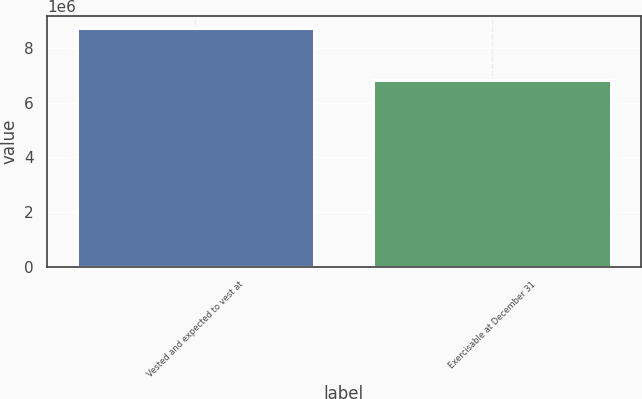Convert chart. <chart><loc_0><loc_0><loc_500><loc_500><bar_chart><fcel>Vested and expected to vest at<fcel>Exercisable at December 31<nl><fcel>8.71883e+06<fcel>6.80602e+06<nl></chart> 